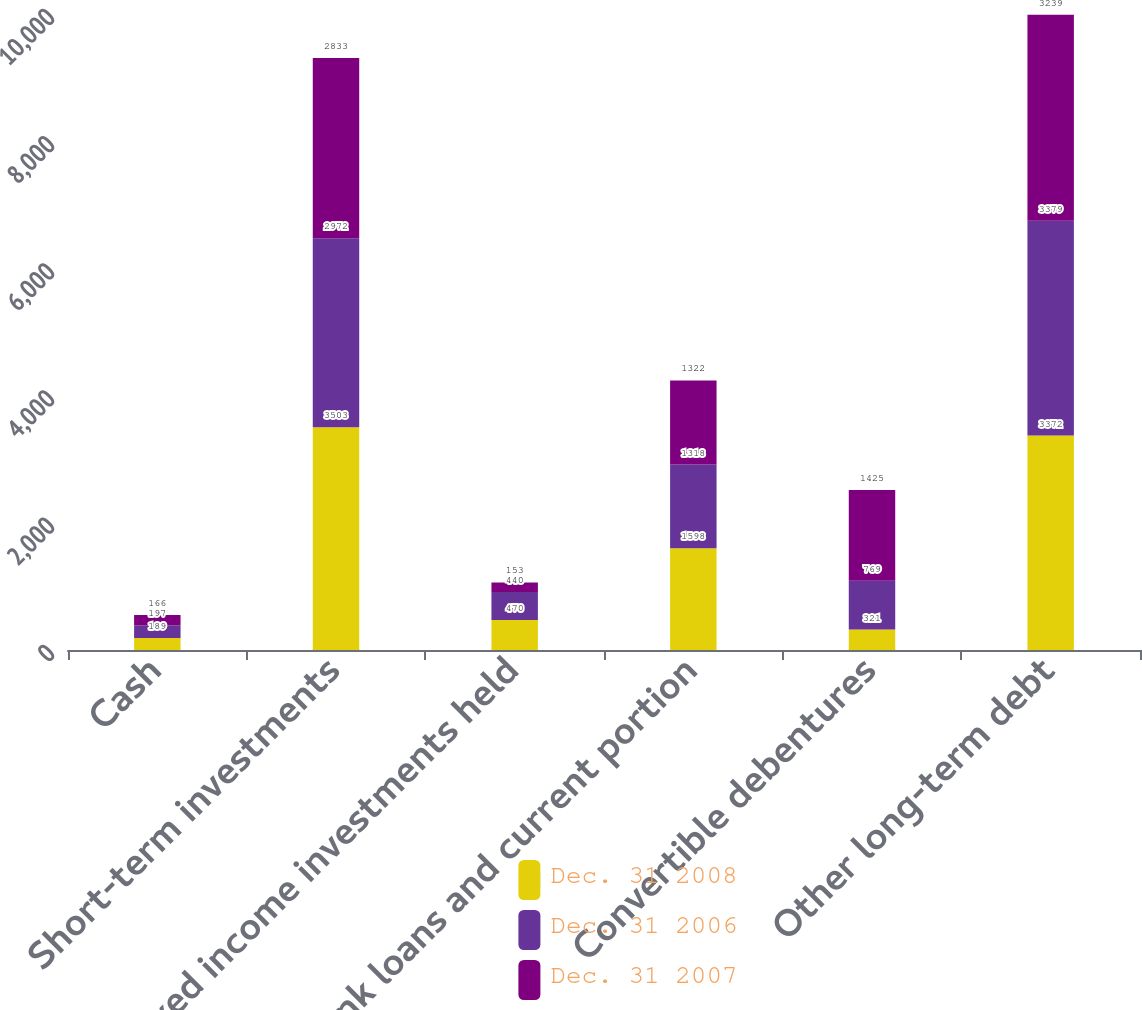Convert chart to OTSL. <chart><loc_0><loc_0><loc_500><loc_500><stacked_bar_chart><ecel><fcel>Cash<fcel>Short-term investments<fcel>Fixed income investments held<fcel>Bank loans and current portion<fcel>Convertible debentures<fcel>Other long-term debt<nl><fcel>Dec. 31 2008<fcel>189<fcel>3503<fcel>470<fcel>1598<fcel>321<fcel>3372<nl><fcel>Dec. 31 2006<fcel>197<fcel>2972<fcel>440<fcel>1318<fcel>769<fcel>3379<nl><fcel>Dec. 31 2007<fcel>166<fcel>2833<fcel>153<fcel>1322<fcel>1425<fcel>3239<nl></chart> 